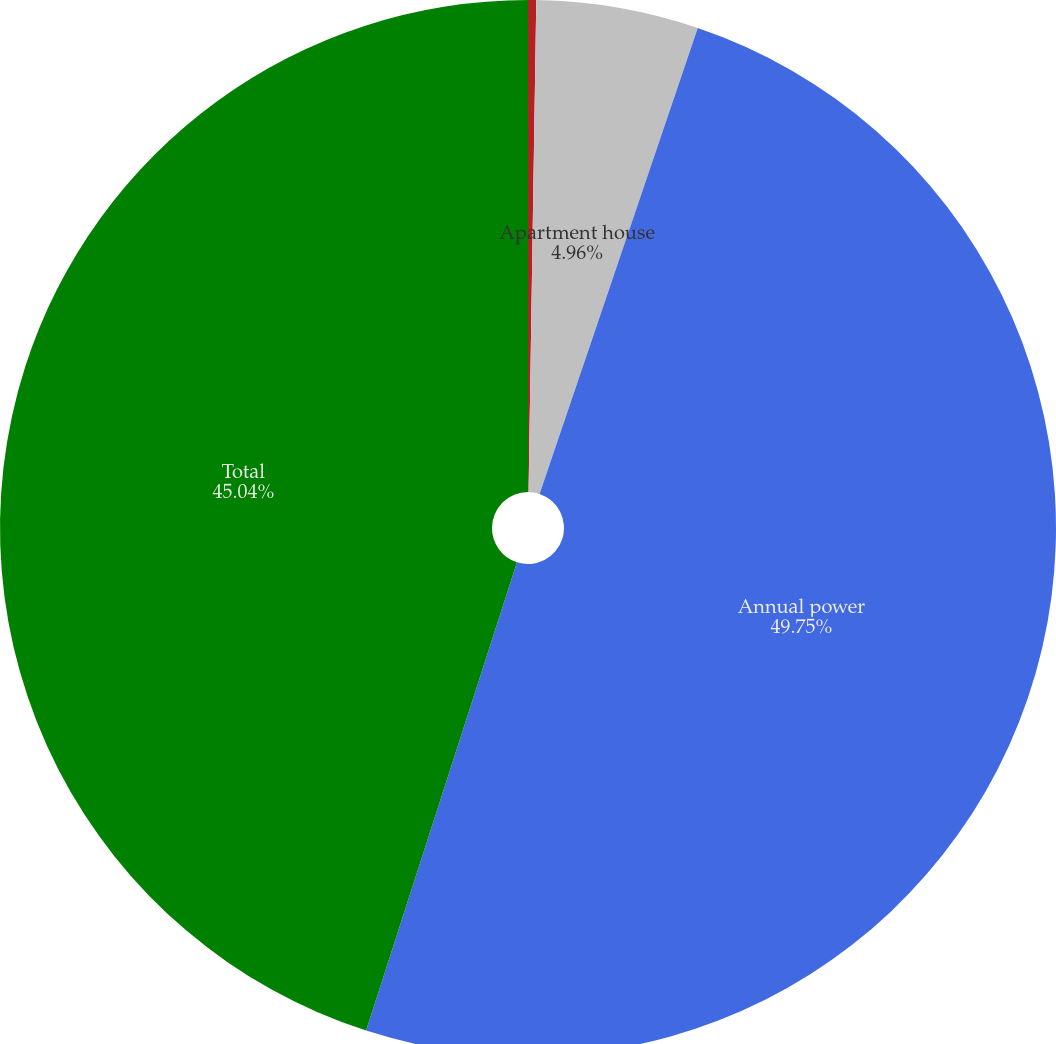Convert chart to OTSL. <chart><loc_0><loc_0><loc_500><loc_500><pie_chart><fcel>General<fcel>Apartment house<fcel>Annual power<fcel>Total<nl><fcel>0.25%<fcel>4.96%<fcel>49.75%<fcel>45.04%<nl></chart> 